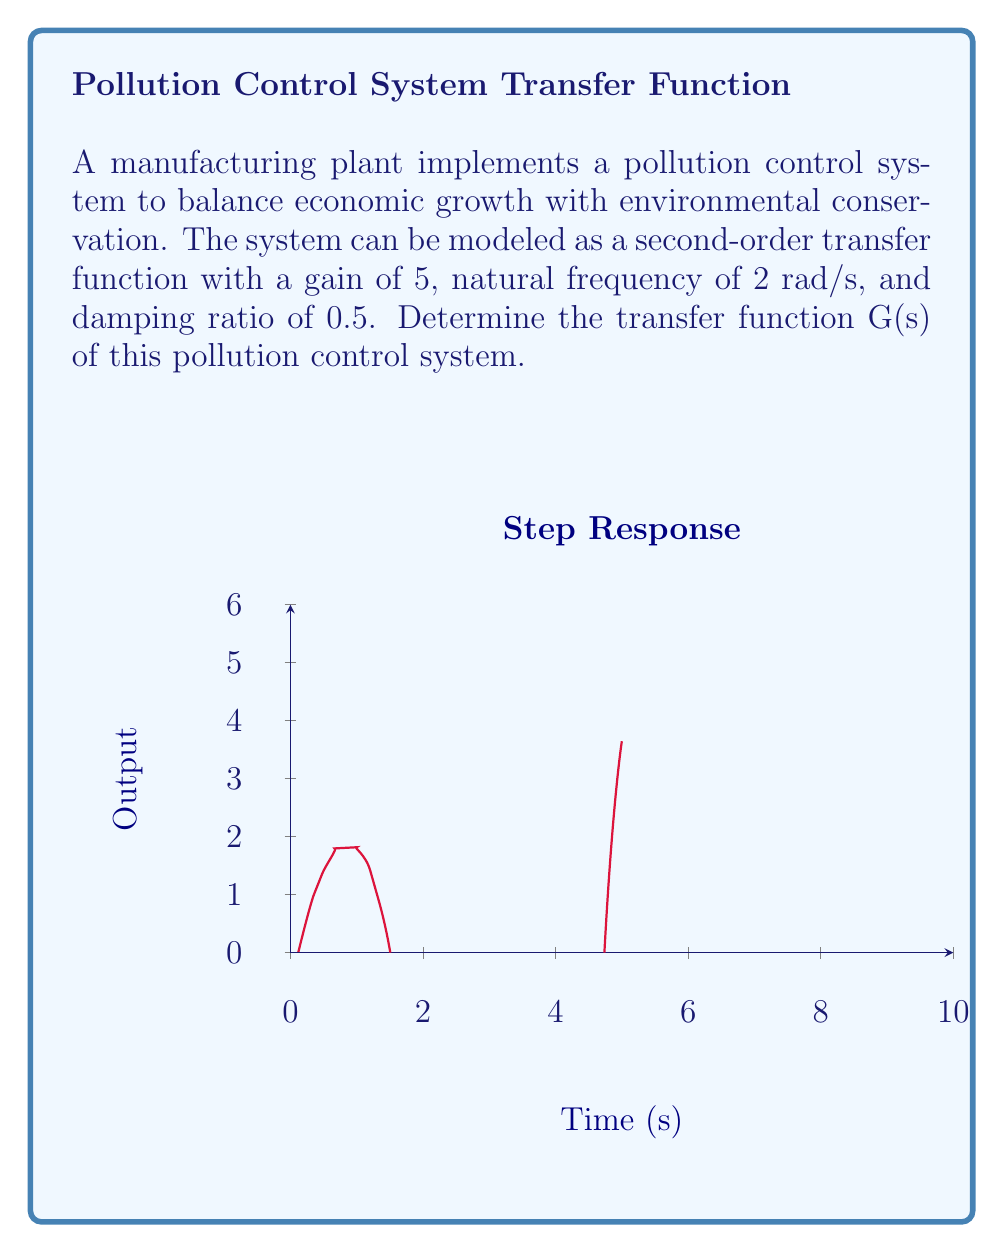Can you solve this math problem? To determine the transfer function, we follow these steps:

1) The general form of a second-order transfer function is:

   $$G(s) = \frac{K\omega_n^2}{s^2 + 2\zeta\omega_n s + \omega_n^2}$$

   where K is the gain, $\omega_n$ is the natural frequency, and $\zeta$ is the damping ratio.

2) We are given:
   K = 5
   $\omega_n$ = 2 rad/s
   $\zeta$ = 0.5

3) Substituting these values into the general form:

   $$G(s) = \frac{5(2)^2}{s^2 + 2(0.5)(2)s + 2^2}$$

4) Simplify:
   $$G(s) = \frac{20}{s^2 + 2s + 4}$$

This transfer function represents how the pollution control system responds to inputs, balancing the need for economic output with environmental protection.
Answer: $$G(s) = \frac{20}{s^2 + 2s + 4}$$ 